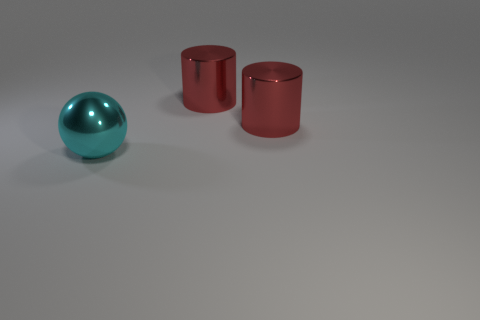Add 1 red objects. How many objects exist? 4 Subtract all spheres. How many objects are left? 2 Add 3 shiny things. How many shiny things are left? 6 Add 3 big shiny things. How many big shiny things exist? 6 Subtract 0 red cubes. How many objects are left? 3 Subtract all large metal objects. Subtract all large brown metallic cylinders. How many objects are left? 0 